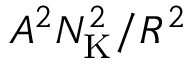Convert formula to latex. <formula><loc_0><loc_0><loc_500><loc_500>A ^ { 2 } N _ { K } ^ { 2 } / R ^ { 2 }</formula> 